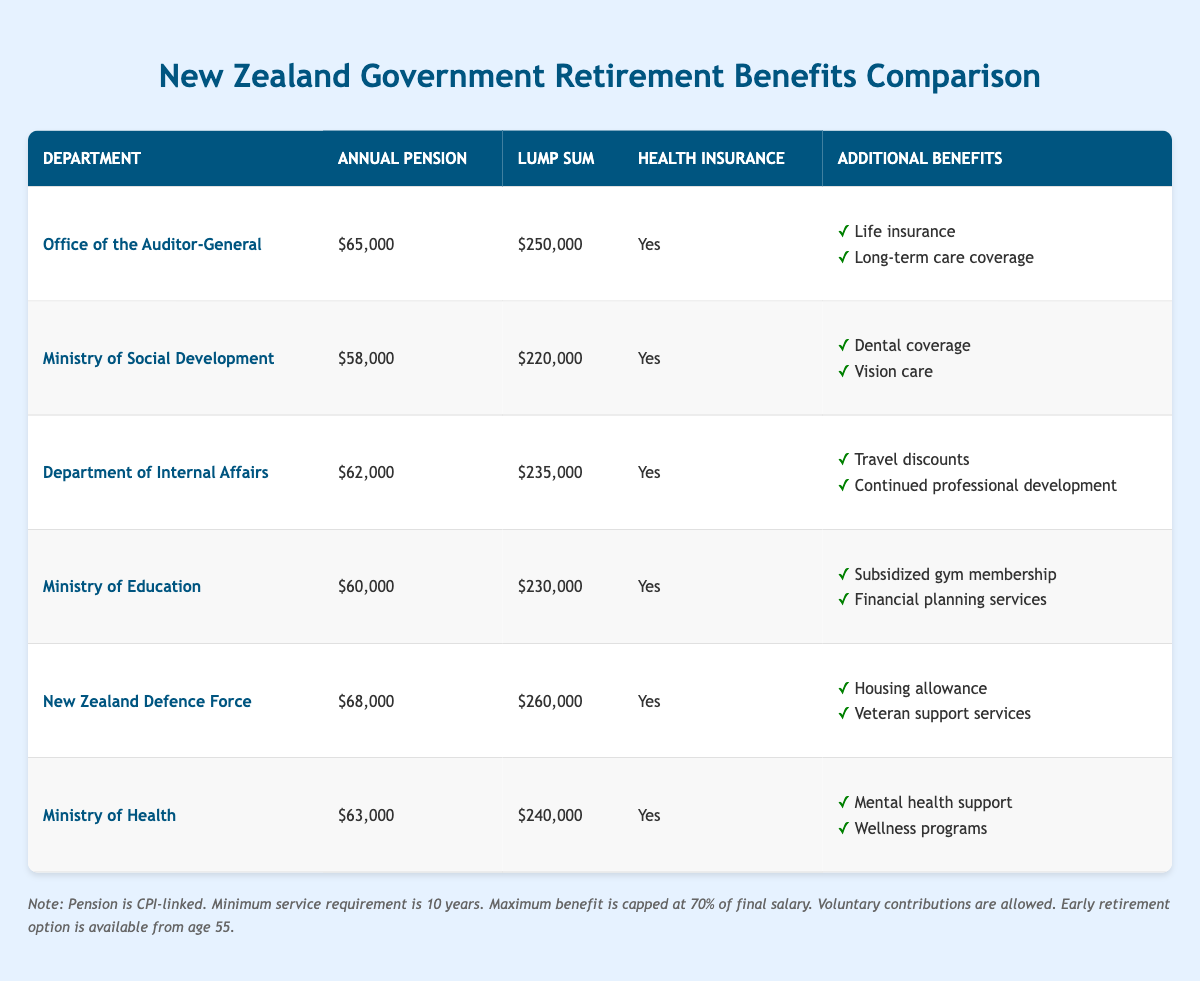What is the annual pension for the New Zealand Defence Force? According to the table, the annual pension listed for the New Zealand Defence Force is $68,000.
Answer: 68,000 Which department offers the highest lump sum payment? The department that offers the highest lump sum payment is the New Zealand Defence Force with a lump sum of $260,000.
Answer: New Zealand Defence Force Does the Ministry of Health provide health insurance as part of its retirement benefits? Yes, the table indicates that the Ministry of Health does provide health insurance under its retirement benefits.
Answer: Yes What is the difference in annual pension between the Ministry of Education and the Ministry of Social Development? The annual pension for the Ministry of Education is $60,000 and for the Ministry of Social Development is $58,000. The difference is $60,000 - $58,000 = $2,000.
Answer: 2,000 How many departments have a lump sum payment of over $240,000? The departments with a lump sum payment over $240,000 are the Office of the Auditor-General, Department of Internal Affairs, New Zealand Defence Force, and Ministry of Health. There are 4 such departments.
Answer: 4 Which department has the same annual pension as the Ministry of Health? The Department of Internal Affairs has an annual pension of $62,000, which is the same as the Ministry of Health at $63,000. However, there is no department with the exact same annual pension as the Ministry of Health.
Answer: None What are the additional benefits provided by the Office of the Auditor-General? According to the table, the additional benefits provided by the Office of the Auditor-General include life insurance and long-term care coverage.
Answer: Life insurance, long-term care coverage What is the average annual pension across all listed departments? To calculate the average annual pension: (65,000 + 58,000 + 62,000 + 60,000 + 68,000 + 63,000) / 6 = 64,000. Thus, the average annual pension is $64,000.
Answer: 64,000 